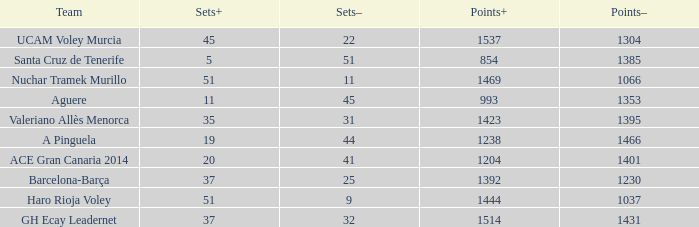What is the highest Points+ number when the Points- number is larger than 1385, a Sets+ number smaller than 37 and a Sets- number larger than 41? 1238.0. Parse the table in full. {'header': ['Team', 'Sets+', 'Sets–', 'Points+', 'Points–'], 'rows': [['UCAM Voley Murcia', '45', '22', '1537', '1304'], ['Santa Cruz de Tenerife', '5', '51', '854', '1385'], ['Nuchar Tramek Murillo', '51', '11', '1469', '1066'], ['Aguere', '11', '45', '993', '1353'], ['Valeriano Allès Menorca', '35', '31', '1423', '1395'], ['A Pinguela', '19', '44', '1238', '1466'], ['ACE Gran Canaria 2014', '20', '41', '1204', '1401'], ['Barcelona-Barça', '37', '25', '1392', '1230'], ['Haro Rioja Voley', '51', '9', '1444', '1037'], ['GH Ecay Leadernet', '37', '32', '1514', '1431']]} 